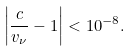<formula> <loc_0><loc_0><loc_500><loc_500>\left | \frac { c } { v _ { \nu } } - 1 \right | < 1 0 ^ { - 8 } .</formula> 